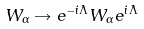Convert formula to latex. <formula><loc_0><loc_0><loc_500><loc_500>W _ { \alpha } \rightarrow e ^ { - i \Lambda } W _ { \alpha } e ^ { i \Lambda }</formula> 